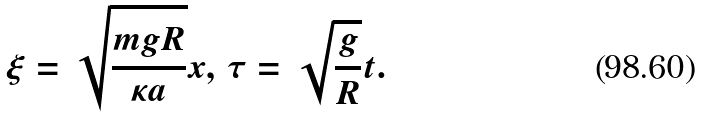<formula> <loc_0><loc_0><loc_500><loc_500>\xi = \sqrt { \frac { m g R } { \kappa a } } x , \, \tau = \sqrt { \frac { g } { R } } t .</formula> 